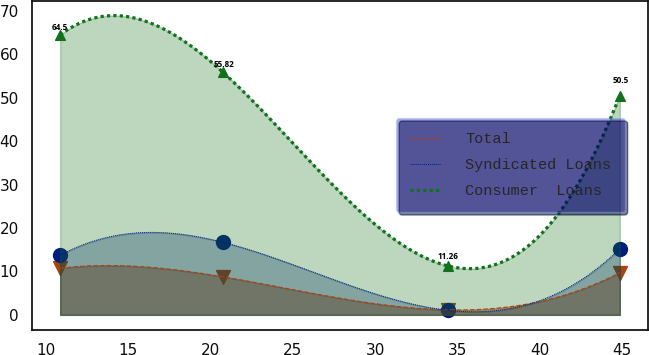<chart> <loc_0><loc_0><loc_500><loc_500><line_chart><ecel><fcel>Total<fcel>Syndicated Loans<fcel>Consumer  Loans<nl><fcel>10.86<fcel>10.75<fcel>13.74<fcel>64.5<nl><fcel>20.77<fcel>8.76<fcel>16.7<fcel>55.82<nl><fcel>34.43<fcel>1.15<fcel>1.06<fcel>11.26<nl><fcel>44.87<fcel>9.72<fcel>15.22<fcel>50.5<nl></chart> 